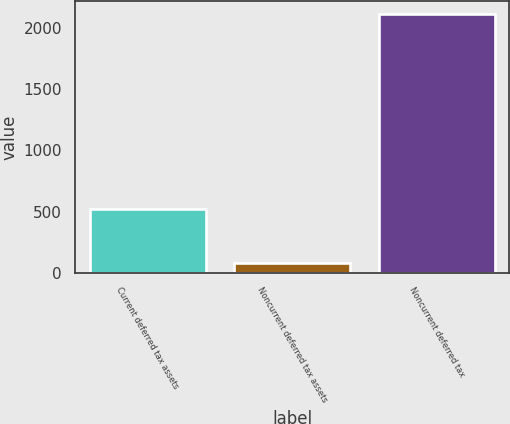Convert chart to OTSL. <chart><loc_0><loc_0><loc_500><loc_500><bar_chart><fcel>Current deferred tax assets<fcel>Noncurrent deferred tax assets<fcel>Noncurrent deferred tax<nl><fcel>522<fcel>80<fcel>2114<nl></chart> 